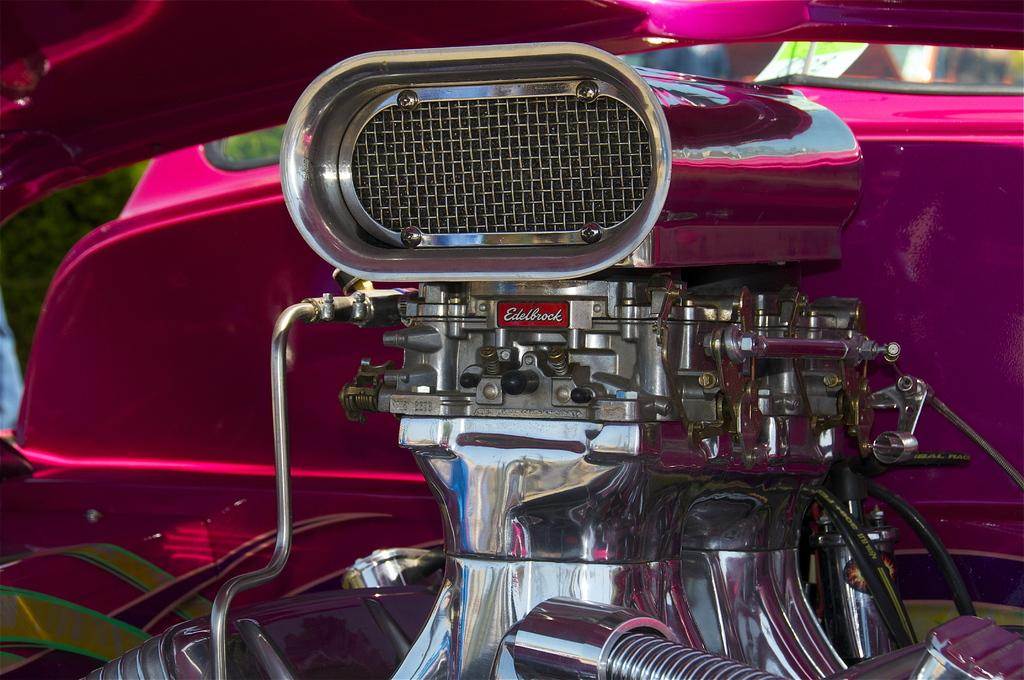What type of object is depicted in the image? There are parts of a bike in the image. How many eyes can be seen on the bike in the image? There are no eyes present on the bike in the image, as bikes do not have eyes. 